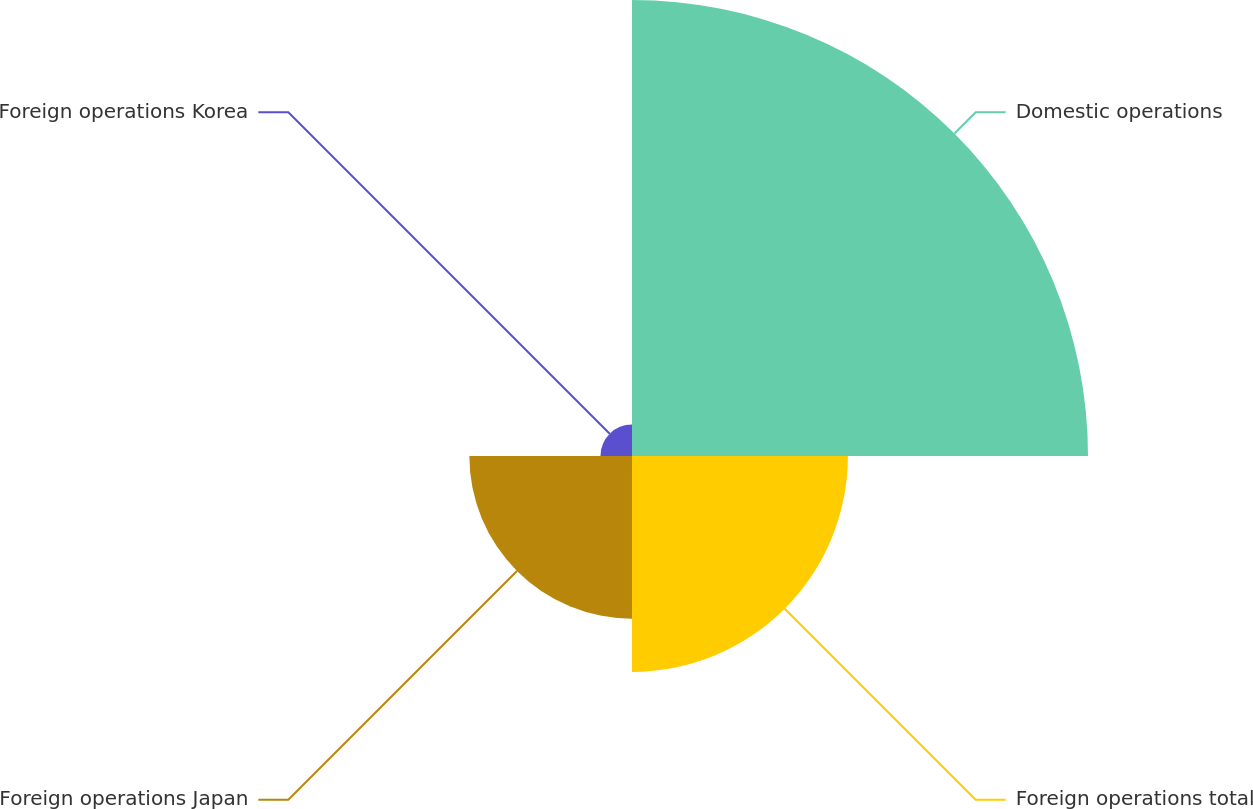Convert chart to OTSL. <chart><loc_0><loc_0><loc_500><loc_500><pie_chart><fcel>Domestic operations<fcel>Foreign operations total<fcel>Foreign operations Japan<fcel>Foreign operations Korea<nl><fcel>52.65%<fcel>24.93%<fcel>18.78%<fcel>3.64%<nl></chart> 